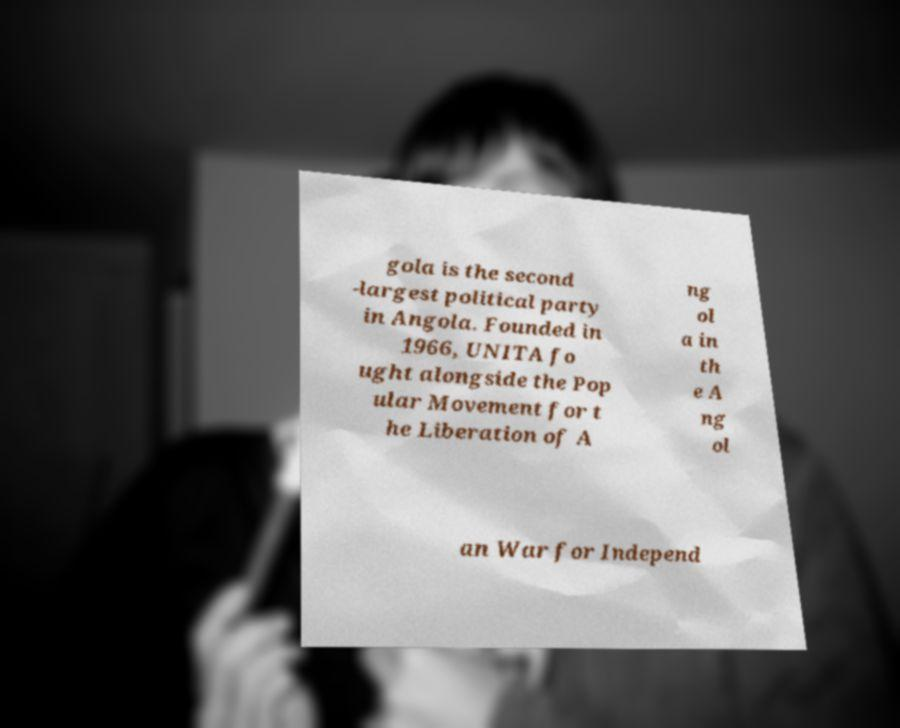I need the written content from this picture converted into text. Can you do that? gola is the second -largest political party in Angola. Founded in 1966, UNITA fo ught alongside the Pop ular Movement for t he Liberation of A ng ol a in th e A ng ol an War for Independ 